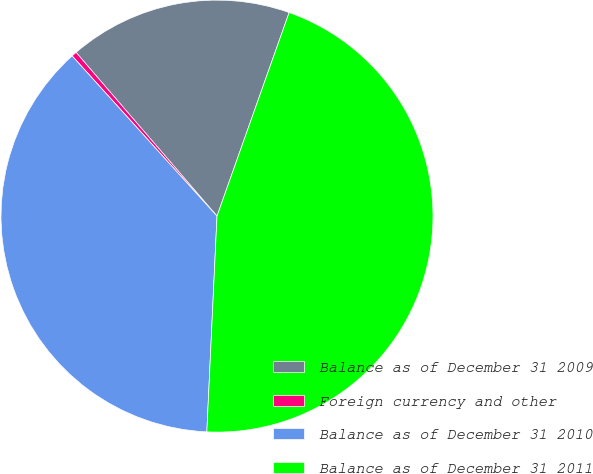Convert chart to OTSL. <chart><loc_0><loc_0><loc_500><loc_500><pie_chart><fcel>Balance as of December 31 2009<fcel>Foreign currency and other<fcel>Balance as of December 31 2010<fcel>Balance as of December 31 2011<nl><fcel>16.73%<fcel>0.39%<fcel>37.55%<fcel>45.33%<nl></chart> 